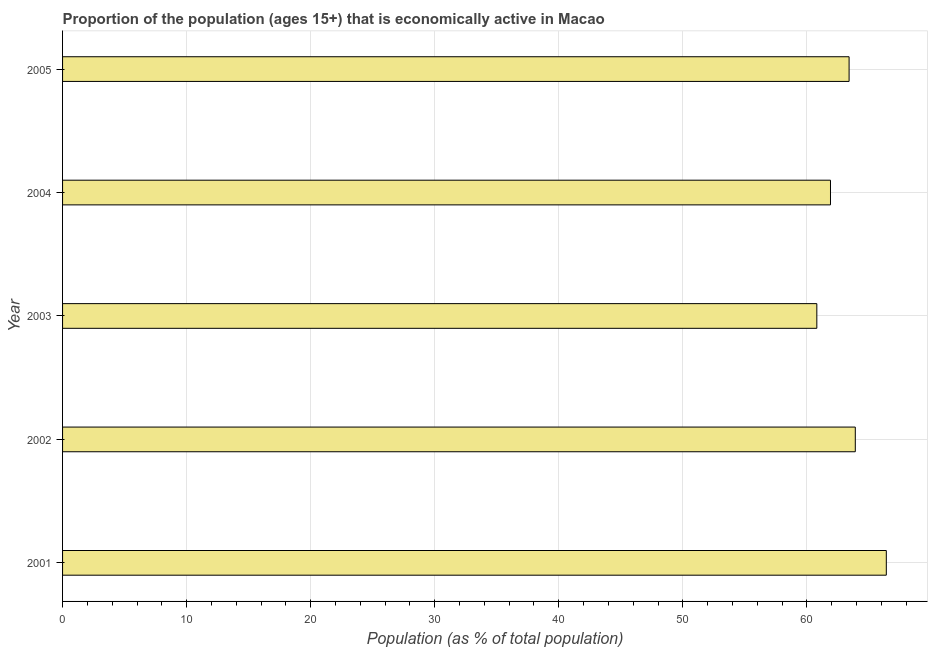What is the title of the graph?
Ensure brevity in your answer.  Proportion of the population (ages 15+) that is economically active in Macao. What is the label or title of the X-axis?
Give a very brief answer. Population (as % of total population). What is the percentage of economically active population in 2004?
Your answer should be very brief. 61.9. Across all years, what is the maximum percentage of economically active population?
Offer a terse response. 66.4. Across all years, what is the minimum percentage of economically active population?
Your response must be concise. 60.8. In which year was the percentage of economically active population maximum?
Your answer should be very brief. 2001. What is the sum of the percentage of economically active population?
Offer a very short reply. 316.4. What is the difference between the percentage of economically active population in 2002 and 2005?
Offer a very short reply. 0.5. What is the average percentage of economically active population per year?
Provide a short and direct response. 63.28. What is the median percentage of economically active population?
Your answer should be very brief. 63.4. Do a majority of the years between 2001 and 2004 (inclusive) have percentage of economically active population greater than 16 %?
Ensure brevity in your answer.  Yes. What is the ratio of the percentage of economically active population in 2004 to that in 2005?
Offer a very short reply. 0.98. What is the difference between the highest and the lowest percentage of economically active population?
Your answer should be compact. 5.6. In how many years, is the percentage of economically active population greater than the average percentage of economically active population taken over all years?
Your answer should be very brief. 3. How many years are there in the graph?
Keep it short and to the point. 5. What is the difference between two consecutive major ticks on the X-axis?
Your answer should be compact. 10. Are the values on the major ticks of X-axis written in scientific E-notation?
Ensure brevity in your answer.  No. What is the Population (as % of total population) of 2001?
Keep it short and to the point. 66.4. What is the Population (as % of total population) of 2002?
Make the answer very short. 63.9. What is the Population (as % of total population) in 2003?
Offer a very short reply. 60.8. What is the Population (as % of total population) in 2004?
Your answer should be very brief. 61.9. What is the Population (as % of total population) in 2005?
Ensure brevity in your answer.  63.4. What is the difference between the Population (as % of total population) in 2001 and 2002?
Your response must be concise. 2.5. What is the difference between the Population (as % of total population) in 2001 and 2003?
Keep it short and to the point. 5.6. What is the difference between the Population (as % of total population) in 2002 and 2003?
Provide a short and direct response. 3.1. What is the difference between the Population (as % of total population) in 2002 and 2004?
Your answer should be very brief. 2. What is the difference between the Population (as % of total population) in 2004 and 2005?
Offer a very short reply. -1.5. What is the ratio of the Population (as % of total population) in 2001 to that in 2002?
Offer a terse response. 1.04. What is the ratio of the Population (as % of total population) in 2001 to that in 2003?
Provide a succinct answer. 1.09. What is the ratio of the Population (as % of total population) in 2001 to that in 2004?
Your answer should be very brief. 1.07. What is the ratio of the Population (as % of total population) in 2001 to that in 2005?
Your response must be concise. 1.05. What is the ratio of the Population (as % of total population) in 2002 to that in 2003?
Provide a short and direct response. 1.05. What is the ratio of the Population (as % of total population) in 2002 to that in 2004?
Offer a very short reply. 1.03. What is the ratio of the Population (as % of total population) in 2004 to that in 2005?
Offer a very short reply. 0.98. 